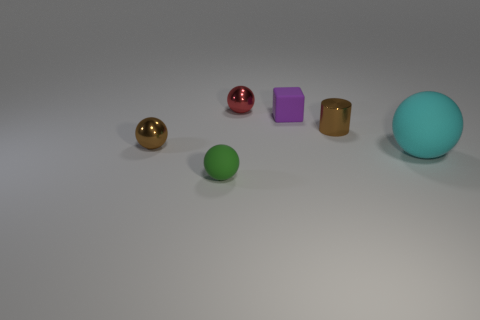What is the shape of the small brown thing right of the rubber ball left of the large rubber object?
Keep it short and to the point. Cylinder. There is a matte thing in front of the large rubber sphere; what number of shiny things are on the left side of it?
Ensure brevity in your answer.  1. What is the object that is both right of the purple thing and behind the big cyan object made of?
Ensure brevity in your answer.  Metal. There is a purple thing that is the same size as the metallic cylinder; what is its shape?
Provide a succinct answer. Cube. What color is the metal sphere that is in front of the small rubber thing behind the brown shiny thing that is to the right of the tiny green matte ball?
Provide a short and direct response. Brown. How many things are either matte objects that are on the left side of the cyan matte thing or tiny green matte spheres?
Your answer should be very brief. 2. There is a brown object that is the same size as the brown cylinder; what material is it?
Offer a terse response. Metal. What is the material of the purple cube that is behind the object that is left of the matte ball on the left side of the small red shiny thing?
Your answer should be very brief. Rubber. What color is the small shiny cylinder?
Your answer should be very brief. Brown. How many small objects are cyan things or brown objects?
Your answer should be very brief. 2. 